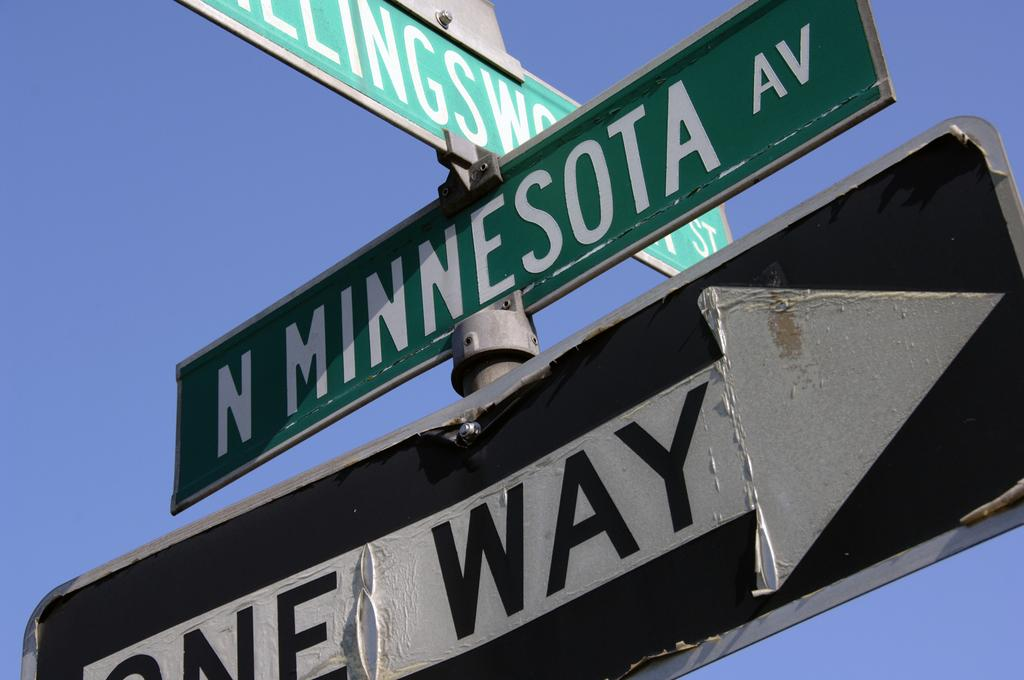Provide a one-sentence caption for the provided image. N Minnesota Av. was the name of the street that is above the one way sign. 